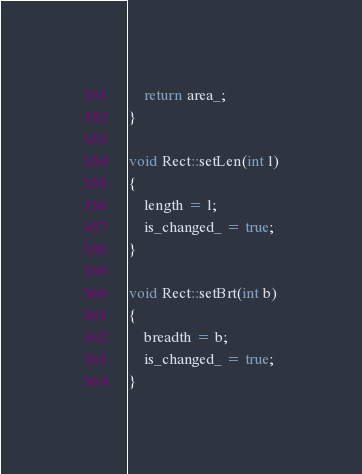<code> <loc_0><loc_0><loc_500><loc_500><_C++_>	return area_;
}

void Rect::setLen(int l)
{
	length = l;
	is_changed_ = true;
}

void Rect::setBrt(int b)
{
	breadth = b;
	is_changed_ = true;
}
</code> 